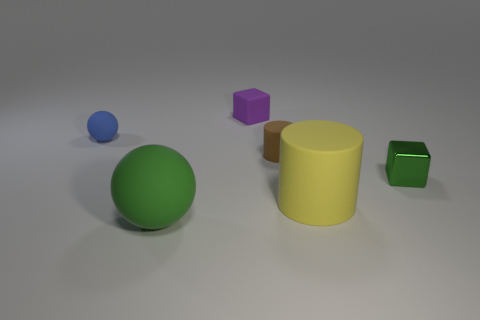Is there anything else that is made of the same material as the green block?
Make the answer very short. No. Is the number of purple rubber objects that are in front of the green sphere less than the number of tiny purple matte blocks?
Provide a short and direct response. Yes. There is a small thing that is on the left side of the tiny purple rubber object to the left of the tiny brown matte cylinder in front of the small blue matte object; what is it made of?
Provide a succinct answer. Rubber. Are there more matte balls that are behind the big rubber ball than brown matte things that are in front of the brown rubber thing?
Your answer should be very brief. Yes. How many rubber things are either tiny things or tiny gray balls?
Keep it short and to the point. 3. What shape is the rubber thing that is the same color as the tiny shiny object?
Make the answer very short. Sphere. What material is the small cube behind the green metallic thing?
Provide a succinct answer. Rubber. What number of objects are either large rubber balls or small things behind the blue rubber thing?
Your response must be concise. 2. There is a green metallic object that is the same size as the brown rubber object; what shape is it?
Offer a terse response. Cube. What number of large rubber cylinders are the same color as the large ball?
Ensure brevity in your answer.  0. 